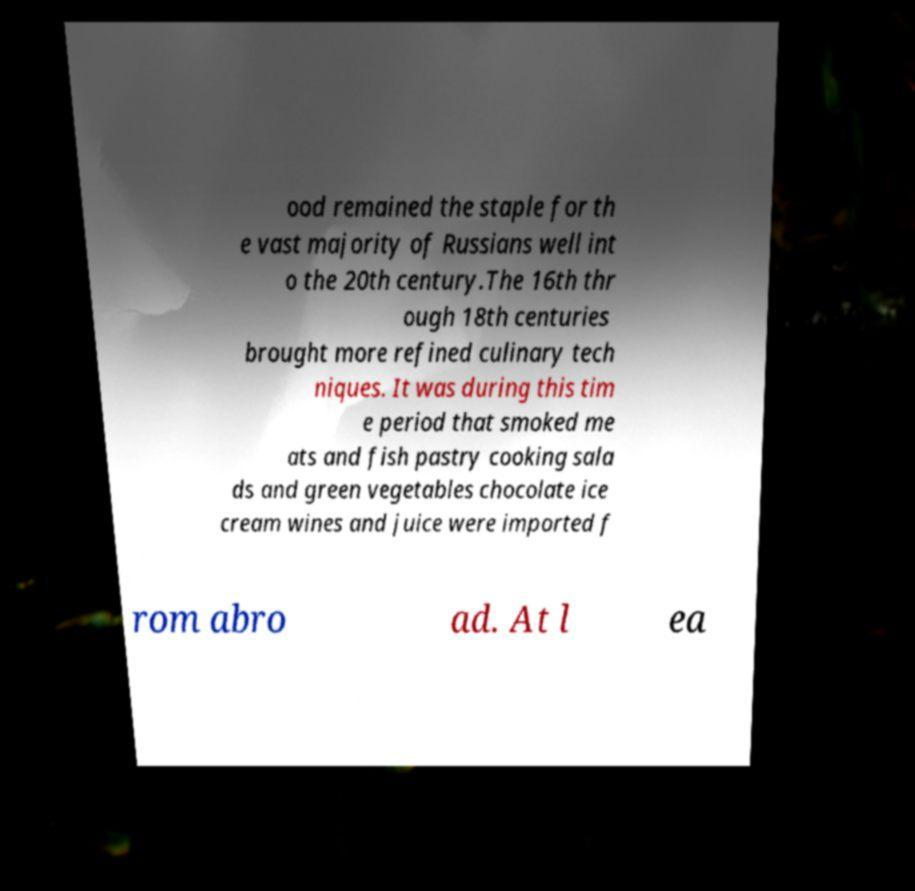Could you extract and type out the text from this image? ood remained the staple for th e vast majority of Russians well int o the 20th century.The 16th thr ough 18th centuries brought more refined culinary tech niques. It was during this tim e period that smoked me ats and fish pastry cooking sala ds and green vegetables chocolate ice cream wines and juice were imported f rom abro ad. At l ea 